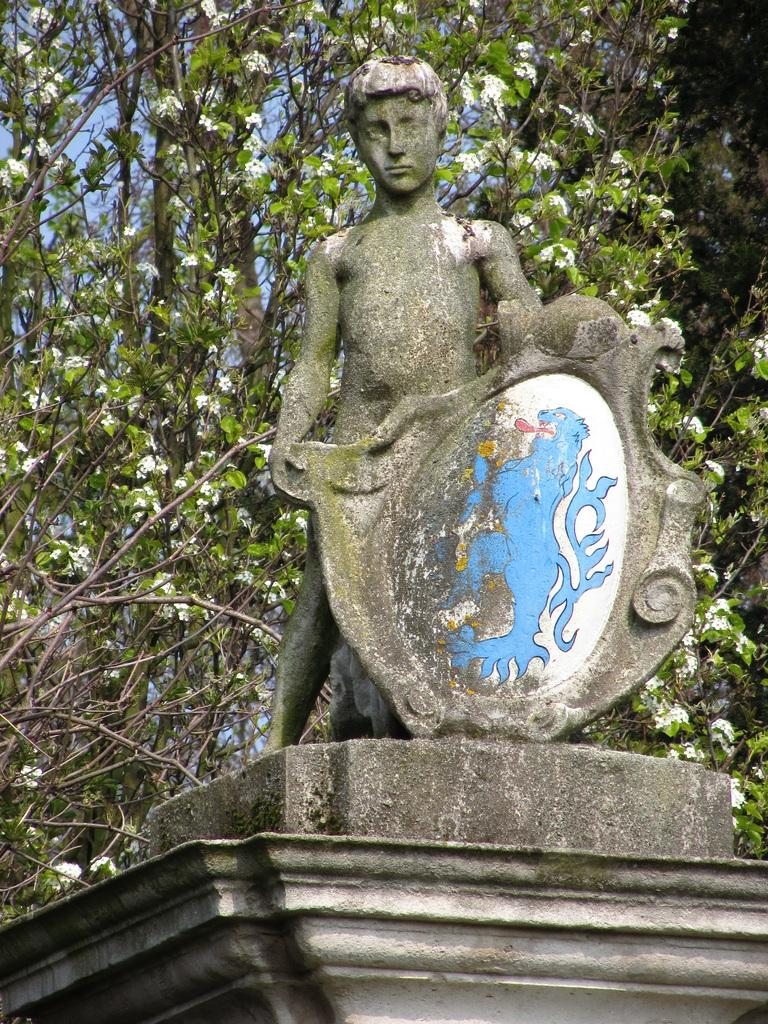What is the main subject in the center of the image? There is a statue in the center of the image. What is located at the bottom of the image? There is a wall at the bottom of the image. What can be seen in the background of the image? There are trees and the sky visible in the background of the image. What type of answer can be seen on the statue in the image? There is no answer present on the statue in the image. How does the statue use its brake in the image? The statue does not have a brake, as it is a non-moving object. 